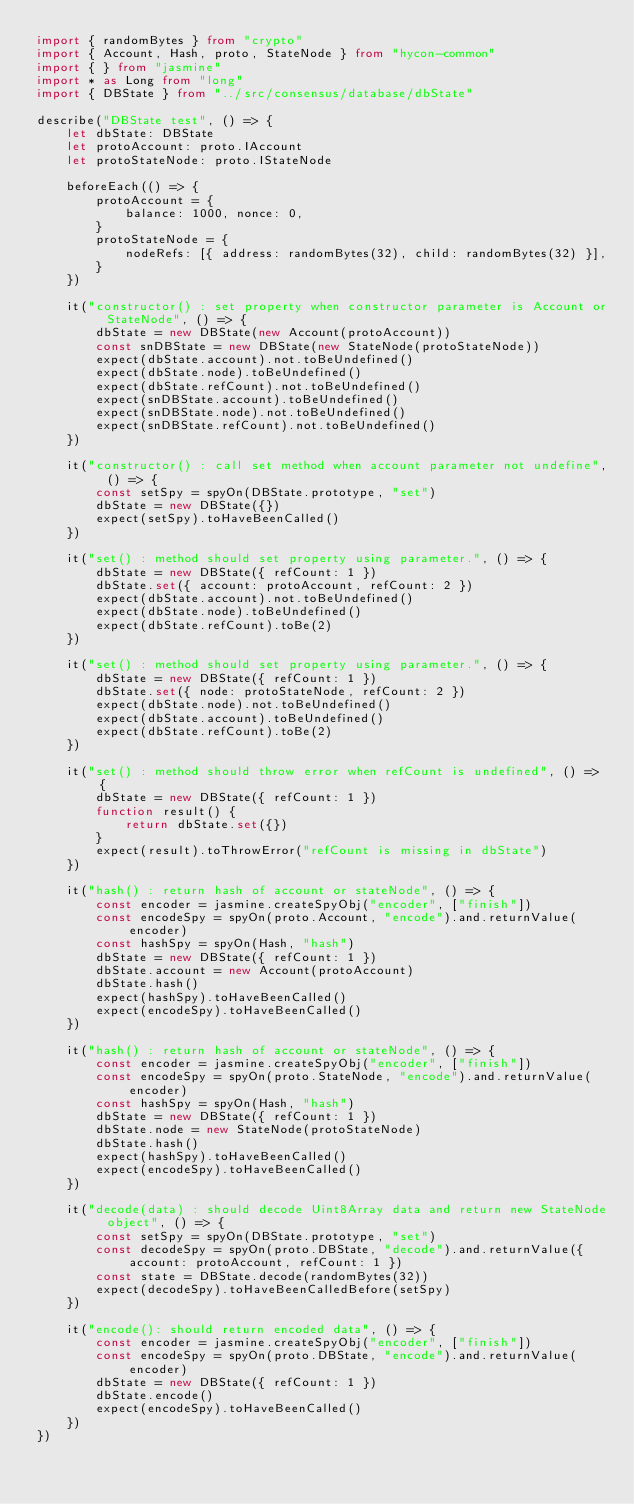<code> <loc_0><loc_0><loc_500><loc_500><_TypeScript_>import { randomBytes } from "crypto"
import { Account, Hash, proto, StateNode } from "hycon-common"
import { } from "jasmine"
import * as Long from "long"
import { DBState } from "../src/consensus/database/dbState"

describe("DBState test", () => {
    let dbState: DBState
    let protoAccount: proto.IAccount
    let protoStateNode: proto.IStateNode

    beforeEach(() => {
        protoAccount = {
            balance: 1000, nonce: 0,
        }
        protoStateNode = {
            nodeRefs: [{ address: randomBytes(32), child: randomBytes(32) }],
        }
    })

    it("constructor() : set property when constructor parameter is Account or StateNode", () => {
        dbState = new DBState(new Account(protoAccount))
        const snDBState = new DBState(new StateNode(protoStateNode))
        expect(dbState.account).not.toBeUndefined()
        expect(dbState.node).toBeUndefined()
        expect(dbState.refCount).not.toBeUndefined()
        expect(snDBState.account).toBeUndefined()
        expect(snDBState.node).not.toBeUndefined()
        expect(snDBState.refCount).not.toBeUndefined()
    })

    it("constructor() : call set method when account parameter not undefine", () => {
        const setSpy = spyOn(DBState.prototype, "set")
        dbState = new DBState({})
        expect(setSpy).toHaveBeenCalled()
    })

    it("set() : method should set property using parameter.", () => {
        dbState = new DBState({ refCount: 1 })
        dbState.set({ account: protoAccount, refCount: 2 })
        expect(dbState.account).not.toBeUndefined()
        expect(dbState.node).toBeUndefined()
        expect(dbState.refCount).toBe(2)
    })

    it("set() : method should set property using parameter.", () => {
        dbState = new DBState({ refCount: 1 })
        dbState.set({ node: protoStateNode, refCount: 2 })
        expect(dbState.node).not.toBeUndefined()
        expect(dbState.account).toBeUndefined()
        expect(dbState.refCount).toBe(2)
    })

    it("set() : method should throw error when refCount is undefined", () => {
        dbState = new DBState({ refCount: 1 })
        function result() {
            return dbState.set({})
        }
        expect(result).toThrowError("refCount is missing in dbState")
    })

    it("hash() : return hash of account or stateNode", () => {
        const encoder = jasmine.createSpyObj("encoder", ["finish"])
        const encodeSpy = spyOn(proto.Account, "encode").and.returnValue(encoder)
        const hashSpy = spyOn(Hash, "hash")
        dbState = new DBState({ refCount: 1 })
        dbState.account = new Account(protoAccount)
        dbState.hash()
        expect(hashSpy).toHaveBeenCalled()
        expect(encodeSpy).toHaveBeenCalled()
    })

    it("hash() : return hash of account or stateNode", () => {
        const encoder = jasmine.createSpyObj("encoder", ["finish"])
        const encodeSpy = spyOn(proto.StateNode, "encode").and.returnValue(encoder)
        const hashSpy = spyOn(Hash, "hash")
        dbState = new DBState({ refCount: 1 })
        dbState.node = new StateNode(protoStateNode)
        dbState.hash()
        expect(hashSpy).toHaveBeenCalled()
        expect(encodeSpy).toHaveBeenCalled()
    })

    it("decode(data) : should decode Uint8Array data and return new StateNode object", () => {
        const setSpy = spyOn(DBState.prototype, "set")
        const decodeSpy = spyOn(proto.DBState, "decode").and.returnValue({ account: protoAccount, refCount: 1 })
        const state = DBState.decode(randomBytes(32))
        expect(decodeSpy).toHaveBeenCalledBefore(setSpy)
    })

    it("encode(): should return encoded data", () => {
        const encoder = jasmine.createSpyObj("encoder", ["finish"])
        const encodeSpy = spyOn(proto.DBState, "encode").and.returnValue(encoder)
        dbState = new DBState({ refCount: 1 })
        dbState.encode()
        expect(encodeSpy).toHaveBeenCalled()
    })
})
</code> 